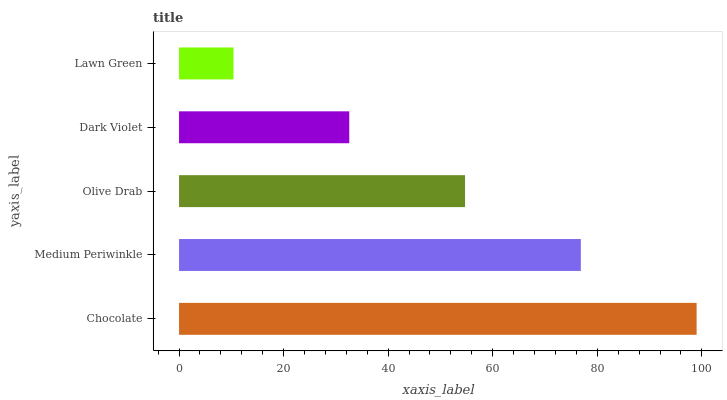Is Lawn Green the minimum?
Answer yes or no. Yes. Is Chocolate the maximum?
Answer yes or no. Yes. Is Medium Periwinkle the minimum?
Answer yes or no. No. Is Medium Periwinkle the maximum?
Answer yes or no. No. Is Chocolate greater than Medium Periwinkle?
Answer yes or no. Yes. Is Medium Periwinkle less than Chocolate?
Answer yes or no. Yes. Is Medium Periwinkle greater than Chocolate?
Answer yes or no. No. Is Chocolate less than Medium Periwinkle?
Answer yes or no. No. Is Olive Drab the high median?
Answer yes or no. Yes. Is Olive Drab the low median?
Answer yes or no. Yes. Is Chocolate the high median?
Answer yes or no. No. Is Chocolate the low median?
Answer yes or no. No. 